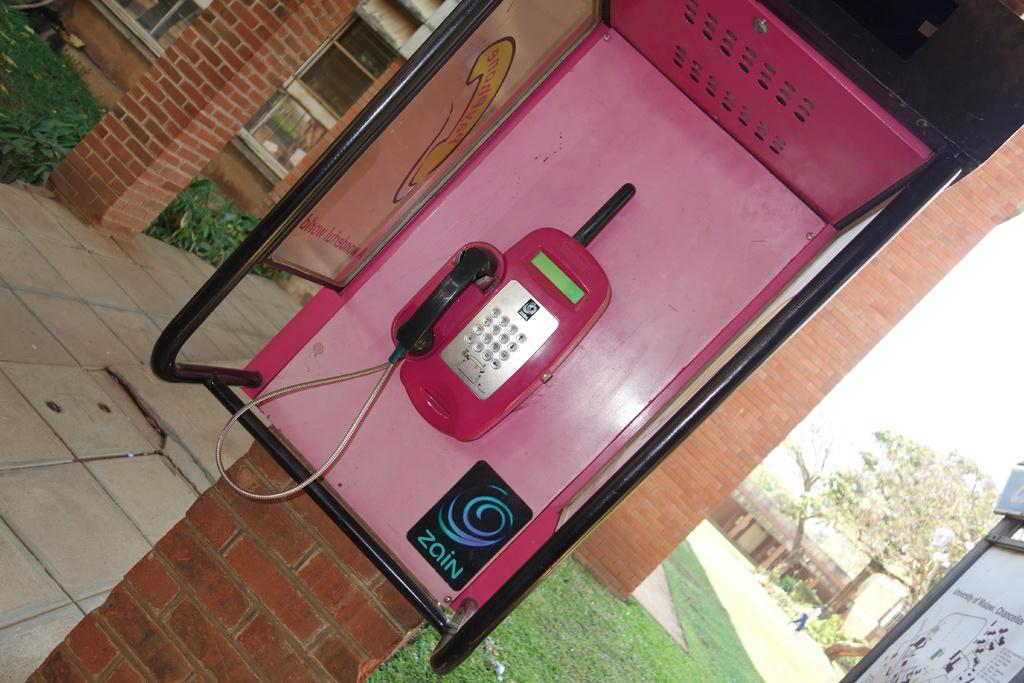Provide a one-sentence caption for the provided image. Pink phone that have a zain symbol at the bottom. 